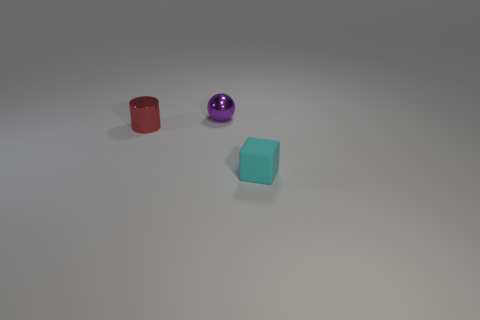What material is the cyan thing that is the same size as the metallic sphere?
Ensure brevity in your answer.  Rubber. Is the number of cylinders greater than the number of big yellow shiny blocks?
Your response must be concise. Yes. How many other objects are there of the same color as the rubber block?
Offer a very short reply. 0. What number of objects are to the left of the small purple thing and to the right of the purple ball?
Ensure brevity in your answer.  0. Is there anything else that is the same size as the cyan rubber thing?
Ensure brevity in your answer.  Yes. Is the number of cylinders that are on the right side of the purple object greater than the number of red things in front of the small cylinder?
Provide a short and direct response. No. What is the material of the small thing that is in front of the small red metallic thing?
Keep it short and to the point. Rubber. There is a tiny matte thing; is it the same shape as the tiny object to the left of the tiny purple metal object?
Give a very brief answer. No. There is a tiny shiny thing that is in front of the small metallic object to the right of the red object; how many small rubber cubes are to the right of it?
Make the answer very short. 1. Are there any other things that have the same shape as the small red shiny object?
Your answer should be very brief. No. 